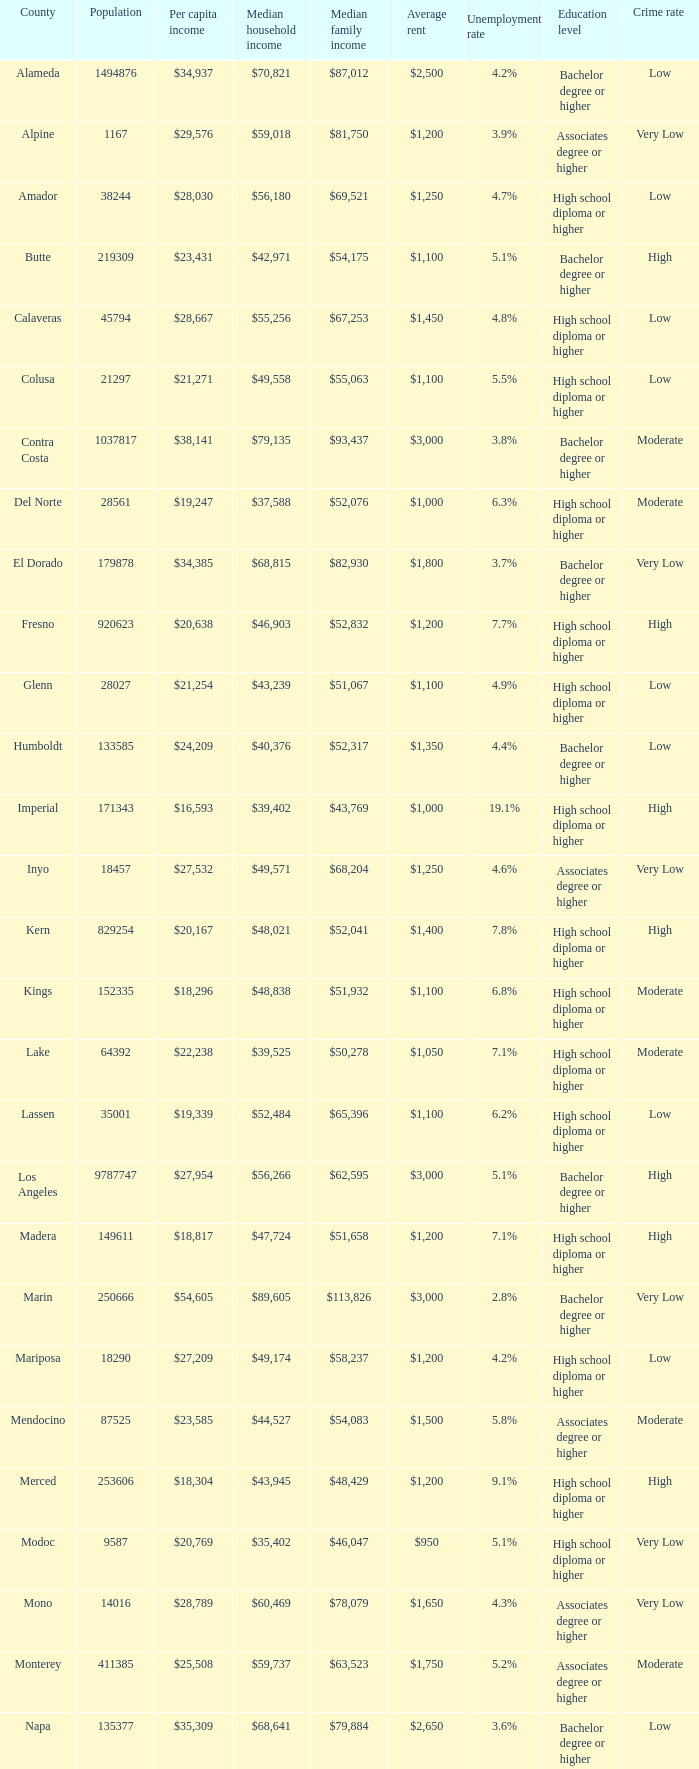What is the average household income in sacramento? $56,553. 